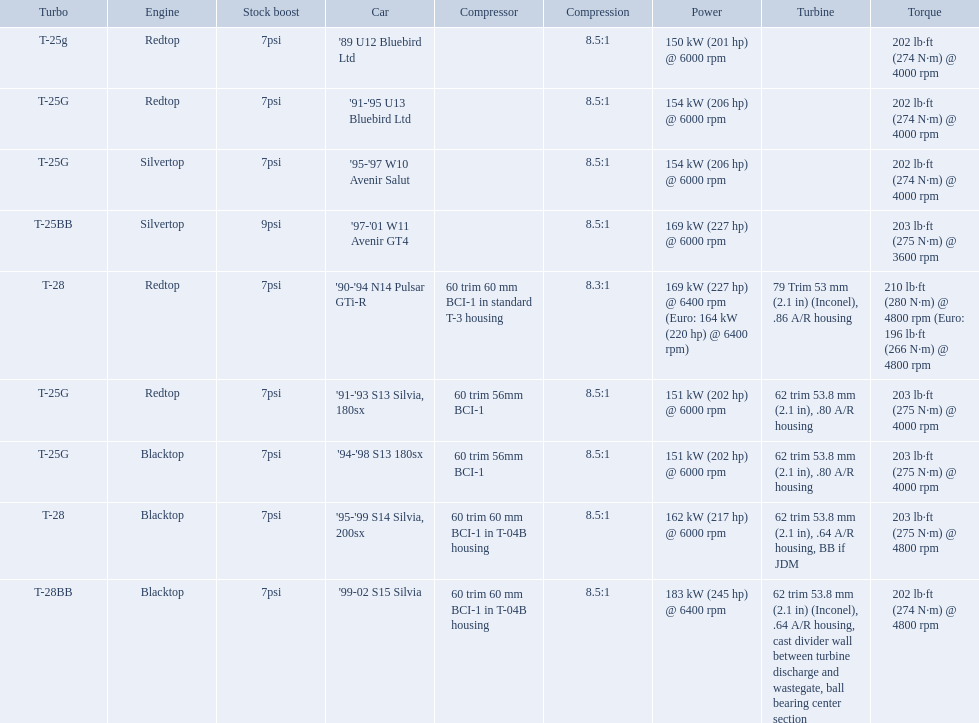What are all of the cars? '89 U12 Bluebird Ltd, '91-'95 U13 Bluebird Ltd, '95-'97 W10 Avenir Salut, '97-'01 W11 Avenir GT4, '90-'94 N14 Pulsar GTi-R, '91-'93 S13 Silvia, 180sx, '94-'98 S13 180sx, '95-'99 S14 Silvia, 200sx, '99-02 S15 Silvia. What is their rated power? 150 kW (201 hp) @ 6000 rpm, 154 kW (206 hp) @ 6000 rpm, 154 kW (206 hp) @ 6000 rpm, 169 kW (227 hp) @ 6000 rpm, 169 kW (227 hp) @ 6400 rpm (Euro: 164 kW (220 hp) @ 6400 rpm), 151 kW (202 hp) @ 6000 rpm, 151 kW (202 hp) @ 6000 rpm, 162 kW (217 hp) @ 6000 rpm, 183 kW (245 hp) @ 6400 rpm. Which car has the most power? '99-02 S15 Silvia. Which of the cars uses the redtop engine? '89 U12 Bluebird Ltd, '91-'95 U13 Bluebird Ltd, '90-'94 N14 Pulsar GTi-R, '91-'93 S13 Silvia, 180sx. Of these, has more than 220 horsepower? '90-'94 N14 Pulsar GTi-R. What is the compression ratio of this car? 8.3:1. What are all the cars? '89 U12 Bluebird Ltd, '91-'95 U13 Bluebird Ltd, '95-'97 W10 Avenir Salut, '97-'01 W11 Avenir GT4, '90-'94 N14 Pulsar GTi-R, '91-'93 S13 Silvia, 180sx, '94-'98 S13 180sx, '95-'99 S14 Silvia, 200sx, '99-02 S15 Silvia. What are their stock boosts? 7psi, 7psi, 7psi, 9psi, 7psi, 7psi, 7psi, 7psi, 7psi. And which car has the highest stock boost? '97-'01 W11 Avenir GT4. What are all of the nissan cars? '89 U12 Bluebird Ltd, '91-'95 U13 Bluebird Ltd, '95-'97 W10 Avenir Salut, '97-'01 W11 Avenir GT4, '90-'94 N14 Pulsar GTi-R, '91-'93 S13 Silvia, 180sx, '94-'98 S13 180sx, '95-'99 S14 Silvia, 200sx, '99-02 S15 Silvia. Of these cars, which one is a '90-'94 n14 pulsar gti-r? '90-'94 N14 Pulsar GTi-R. What is the compression of this car? 8.3:1. Which cars featured blacktop engines? '94-'98 S13 180sx, '95-'99 S14 Silvia, 200sx, '99-02 S15 Silvia. Which of these had t-04b compressor housings? '95-'99 S14 Silvia, 200sx, '99-02 S15 Silvia. Which one of these has the highest horsepower? '99-02 S15 Silvia. Which cars list turbine details? '90-'94 N14 Pulsar GTi-R, '91-'93 S13 Silvia, 180sx, '94-'98 S13 180sx, '95-'99 S14 Silvia, 200sx, '99-02 S15 Silvia. Which of these hit their peak hp at the highest rpm? '90-'94 N14 Pulsar GTi-R, '99-02 S15 Silvia. Of those what is the compression of the only engine that isn't blacktop?? 8.3:1. 